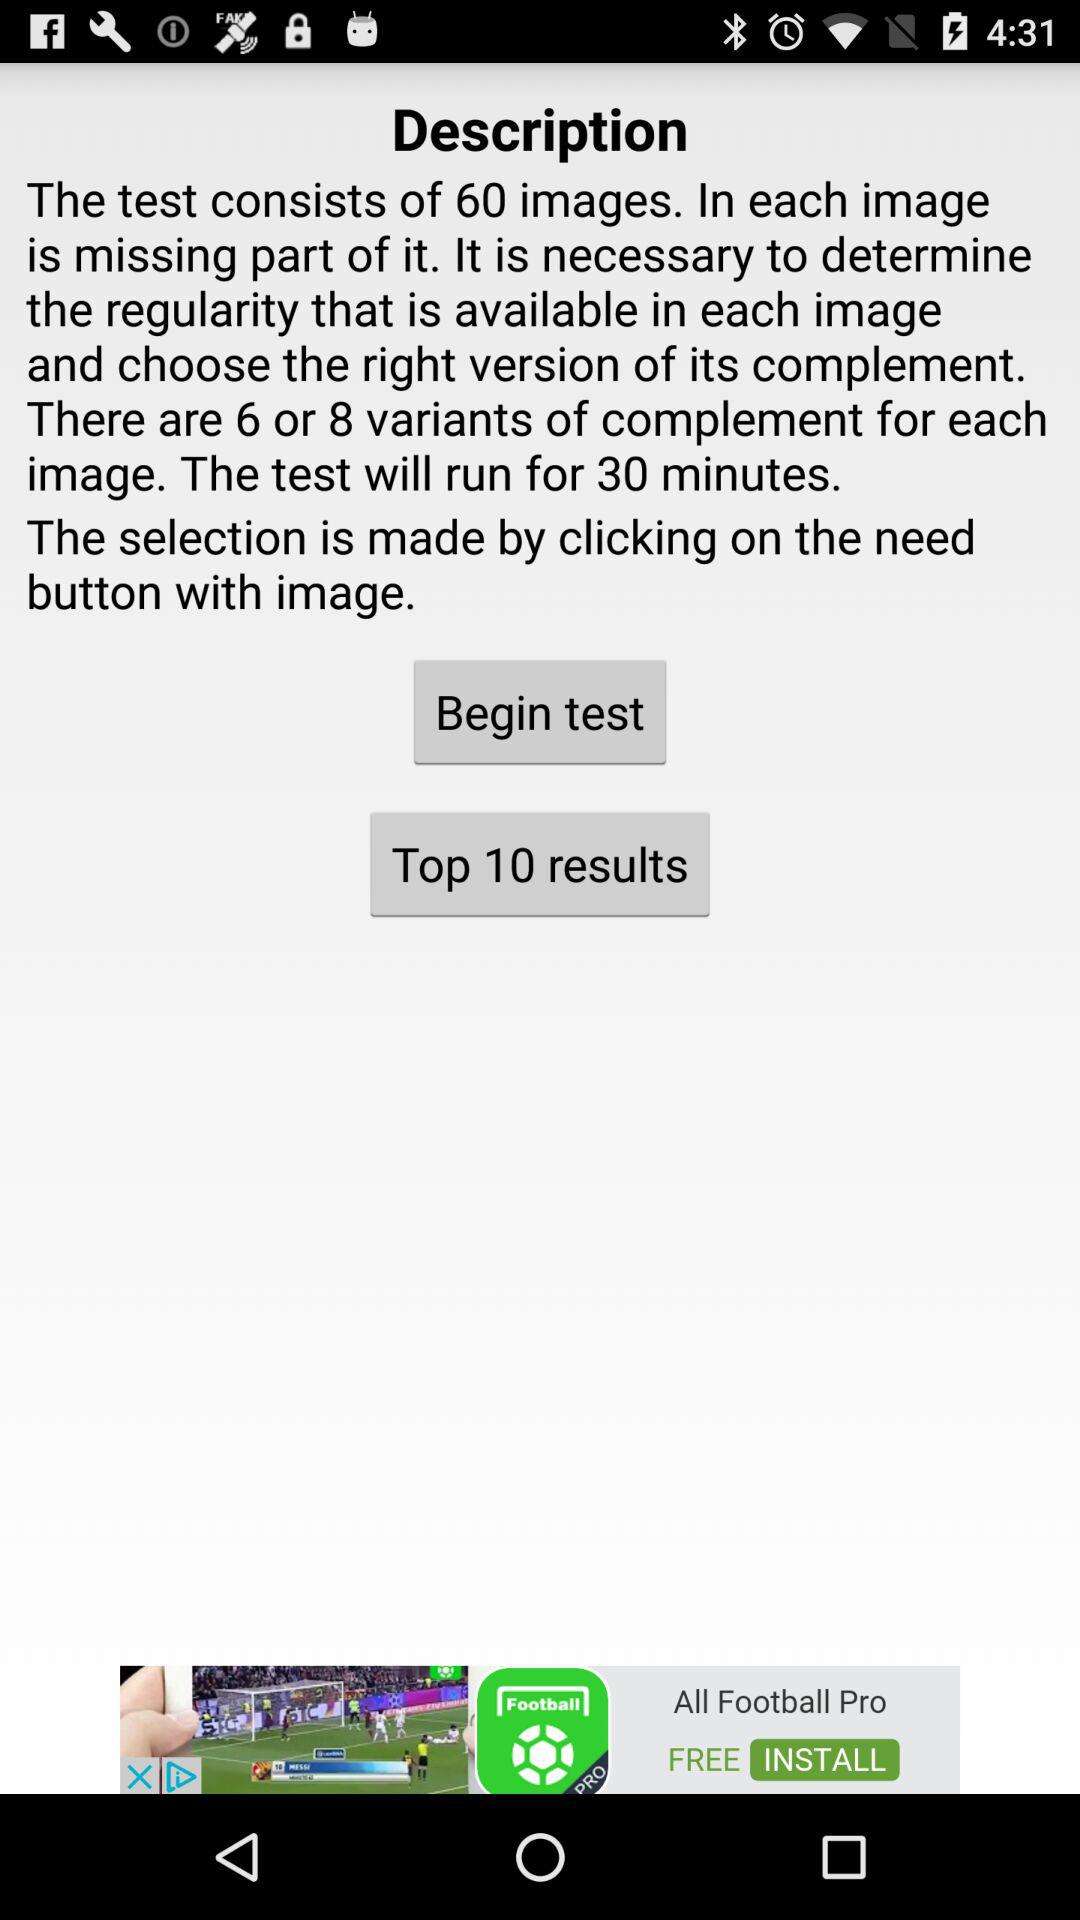How many minutes is the test?
Answer the question using a single word or phrase. 30 